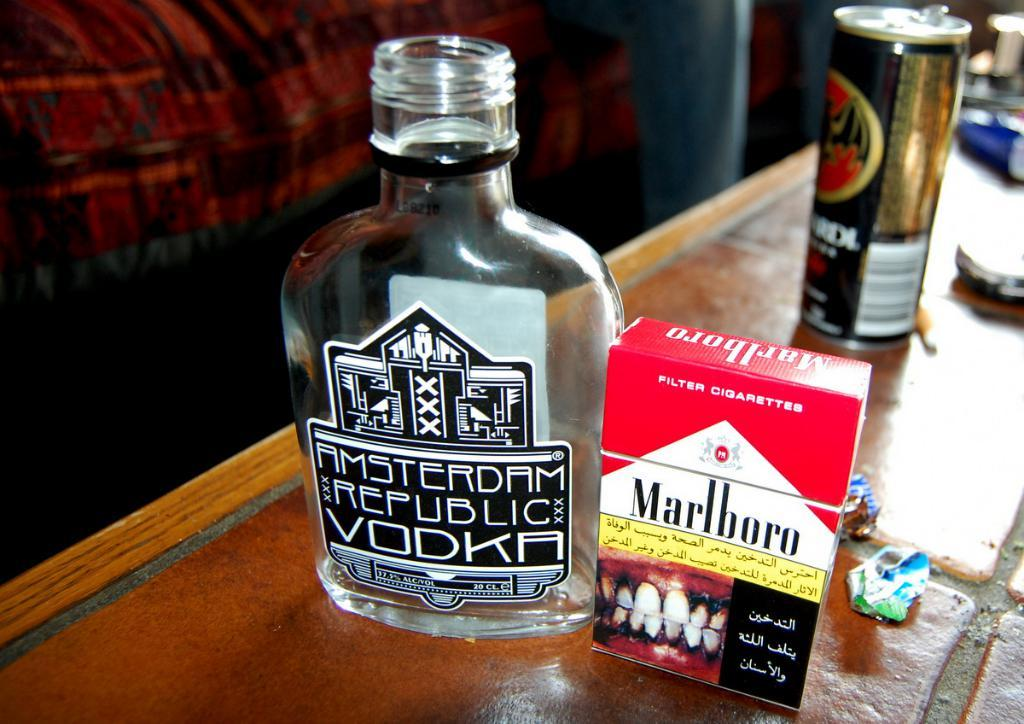Provide a one-sentence caption for the provided image. A bottle of Amsterdam Republic Vodka next to a box of Marlboro cigarettes. 